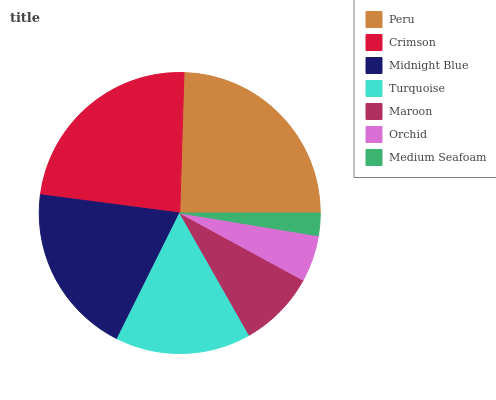Is Medium Seafoam the minimum?
Answer yes or no. Yes. Is Peru the maximum?
Answer yes or no. Yes. Is Crimson the minimum?
Answer yes or no. No. Is Crimson the maximum?
Answer yes or no. No. Is Peru greater than Crimson?
Answer yes or no. Yes. Is Crimson less than Peru?
Answer yes or no. Yes. Is Crimson greater than Peru?
Answer yes or no. No. Is Peru less than Crimson?
Answer yes or no. No. Is Turquoise the high median?
Answer yes or no. Yes. Is Turquoise the low median?
Answer yes or no. Yes. Is Medium Seafoam the high median?
Answer yes or no. No. Is Maroon the low median?
Answer yes or no. No. 